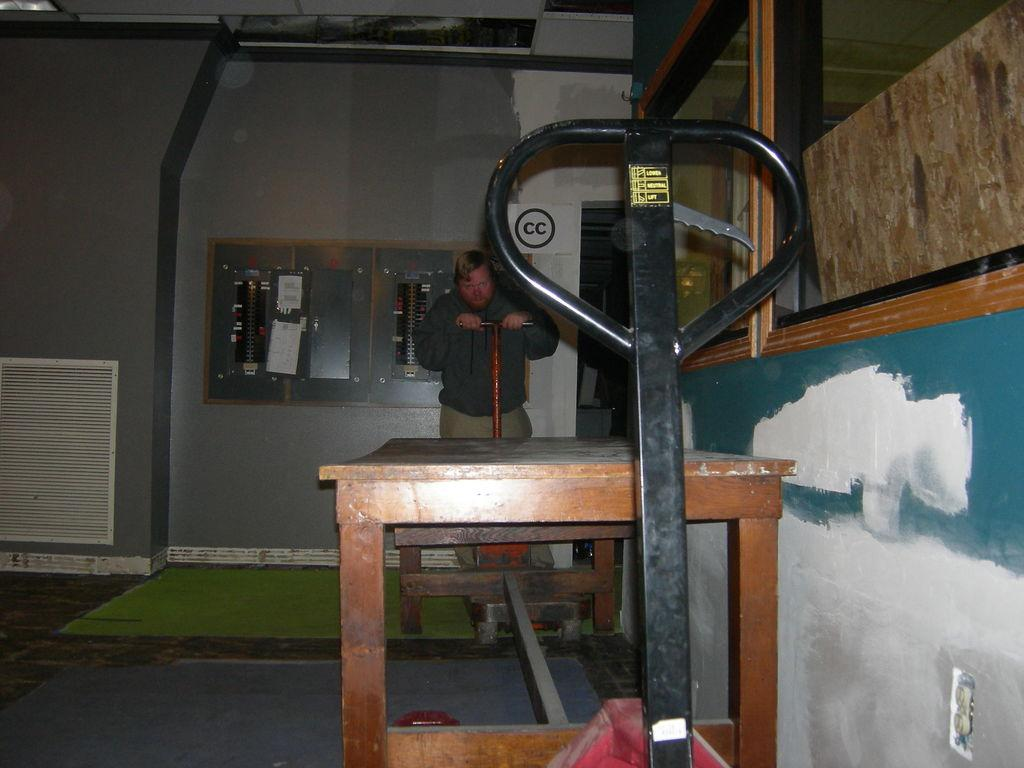Who is present in the room in the image? There is a guy in the room. What is the guy holding in the image? The guy is holding a rod. What piece of furniture can be seen in the room? There is a desk in the room. What is located in front of the desk? There are some things in front of the desk. What type of border can be seen on the desk in the image? There is no border visible on the desk in the image. Is there a knife on the desk in the image? There is no knife present on the desk in the image. 